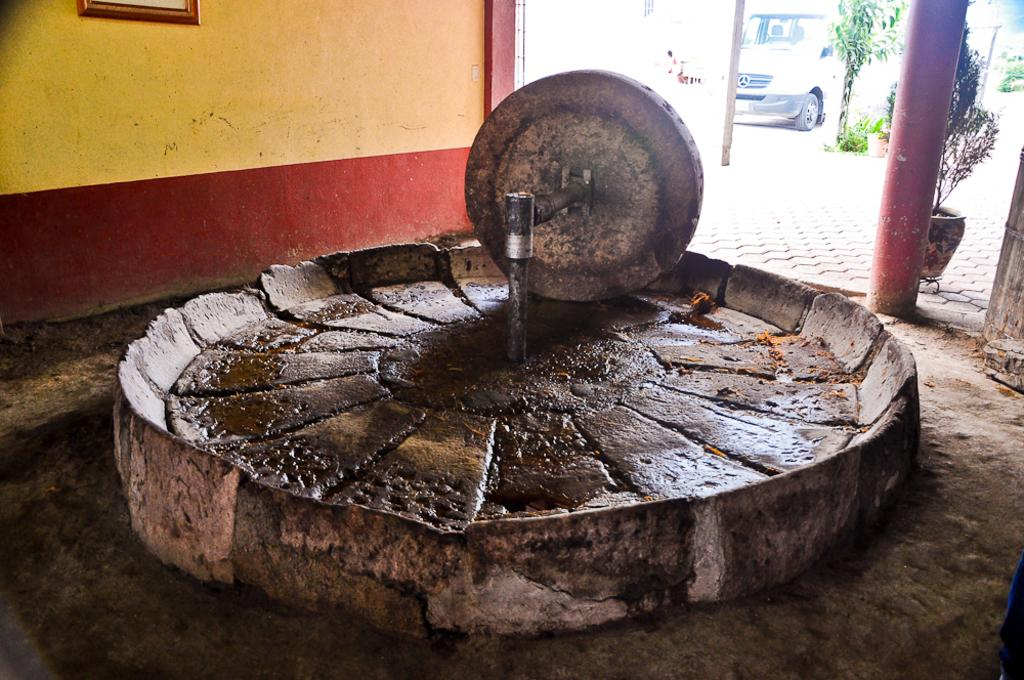What is the main object in the image? There is an object in the image, but its specific nature is not mentioned in the facts. What type of plants can be seen in the image? There are house plants in the image. What architectural feature is present in the image? There is a pillar in the image. What is hanging on the wall in the image? There is a frame on the wall in the image. What can be seen in the background of the image? There is a vehicle in the background of the image. Where is the tub located in the image? There is no tub present in the image. What type of shock can be seen affecting the cattle in the image? There is no cattle present in the image, and therefore no shock can be observed. 